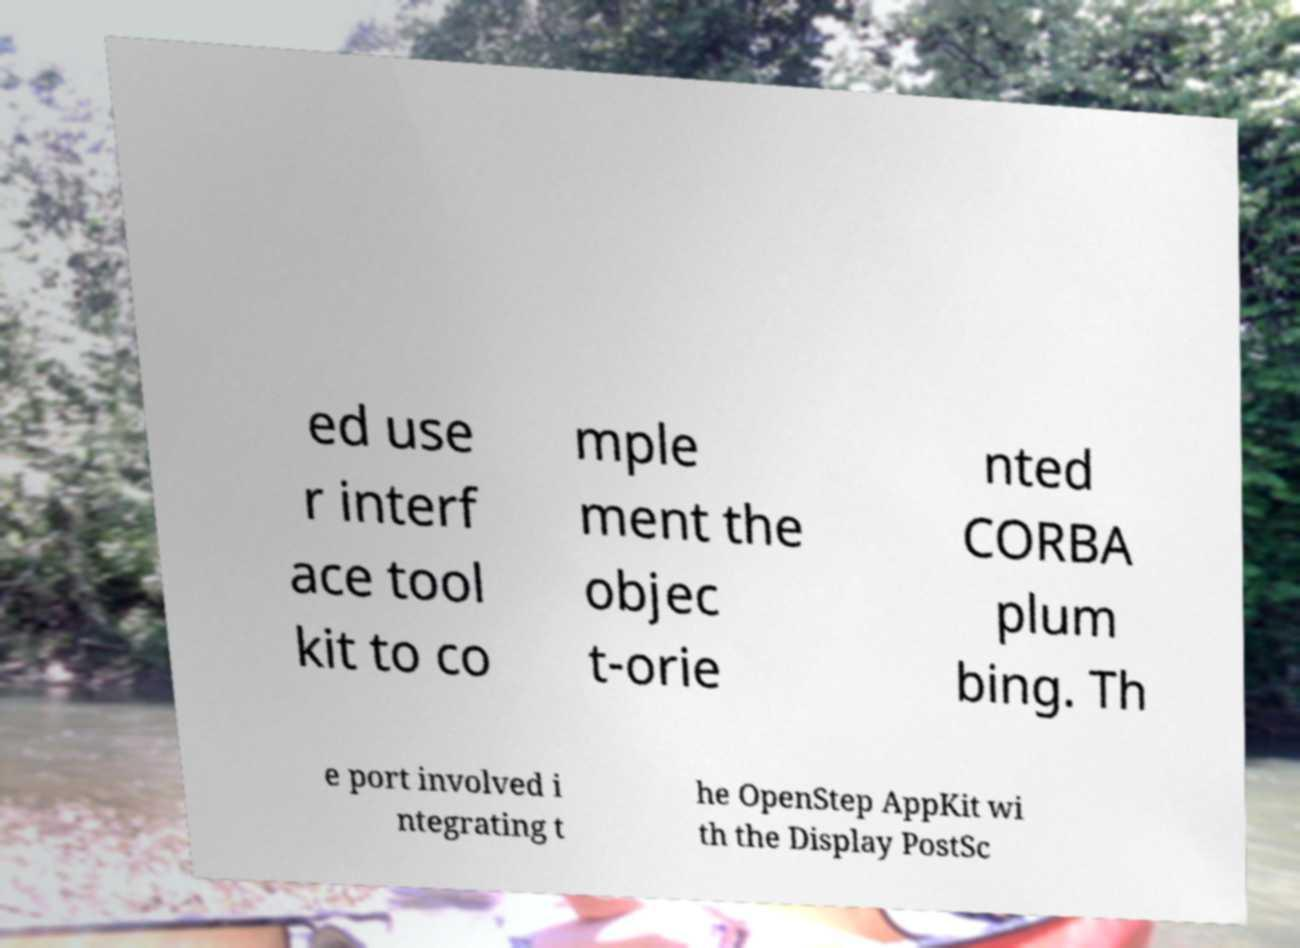Can you read and provide the text displayed in the image?This photo seems to have some interesting text. Can you extract and type it out for me? ed use r interf ace tool kit to co mple ment the objec t-orie nted CORBA plum bing. Th e port involved i ntegrating t he OpenStep AppKit wi th the Display PostSc 